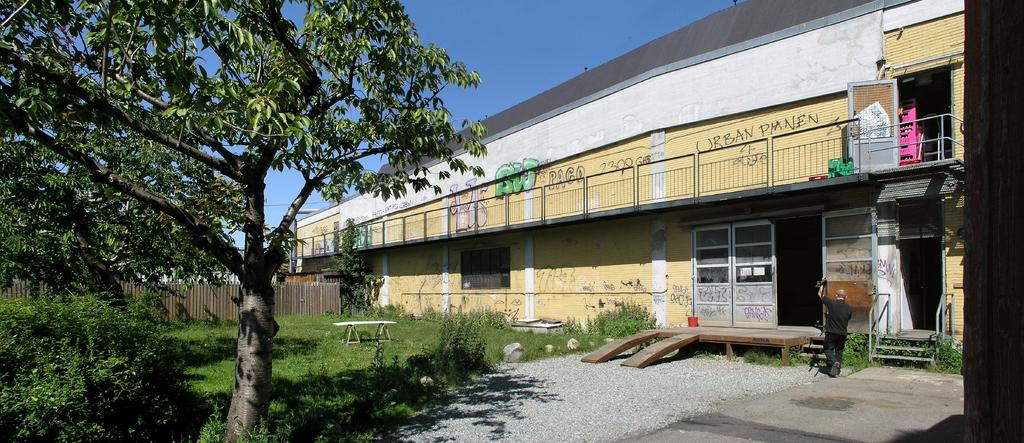What type of structure is in the image? There is a building in the image. What is the person holding in the image? The person is holding an object in the image. What type of vegetation can be seen on one side of the image? Trees are visible on one side of the image. What other types of vegetation are present in the image? Plants and grass are visible in the image. What invention can be seen in the hands of the person in the image? There is no specific invention mentioned in the image; the person is simply holding an object. What breed of dog is running through the grass in the image? There is no dog present in the image; only a building, a person, trees, plants, and grass are visible. 